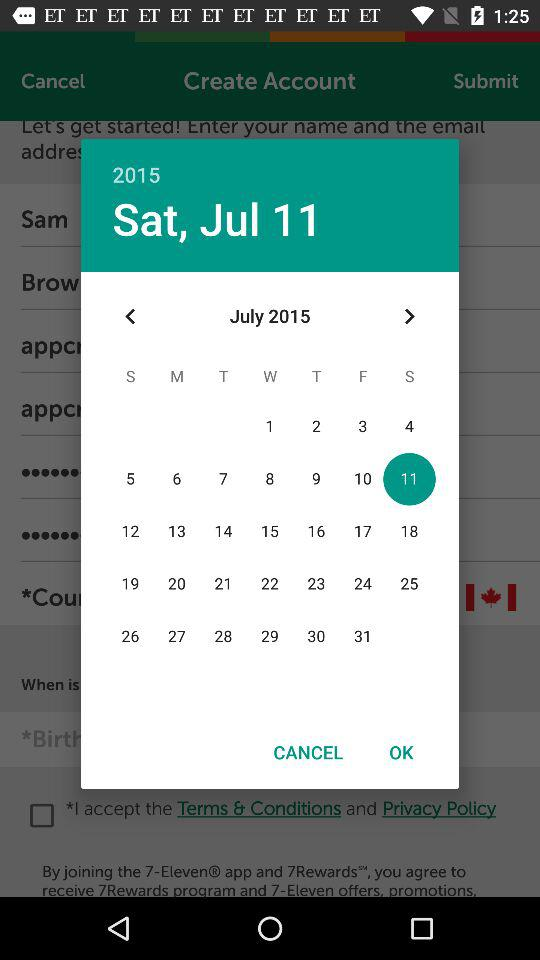Which date is selected? The selected date is Saturday, July 11, 2015. 